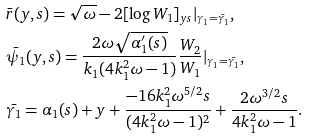<formula> <loc_0><loc_0><loc_500><loc_500>& \bar { r } ( y , s ) = \sqrt { \omega } - 2 [ \log W _ { 1 } ] _ { y s } | _ { \gamma _ { 1 } = \bar { \gamma _ { 1 } } } , \\ & \bar { \psi _ { 1 } } ( y , s ) = \frac { 2 \omega \sqrt { \alpha _ { 1 } ^ { \prime } ( s ) } } { k _ { 1 } ( 4 k _ { 1 } ^ { 2 } \omega - 1 ) } \frac { W _ { 2 } } { W _ { 1 } } | _ { \gamma _ { 1 } = \bar { \gamma _ { 1 } } } , \\ & \bar { \gamma _ { 1 } } = \alpha _ { 1 } ( s ) + y + \frac { - 1 6 k _ { 1 } ^ { 2 } \omega ^ { 5 / 2 } s } { ( 4 k _ { 1 } ^ { 2 } \omega - 1 ) ^ { 2 } } + \frac { 2 \omega ^ { 3 / 2 } s } { 4 k _ { 1 } ^ { 2 } \omega - 1 } .</formula> 